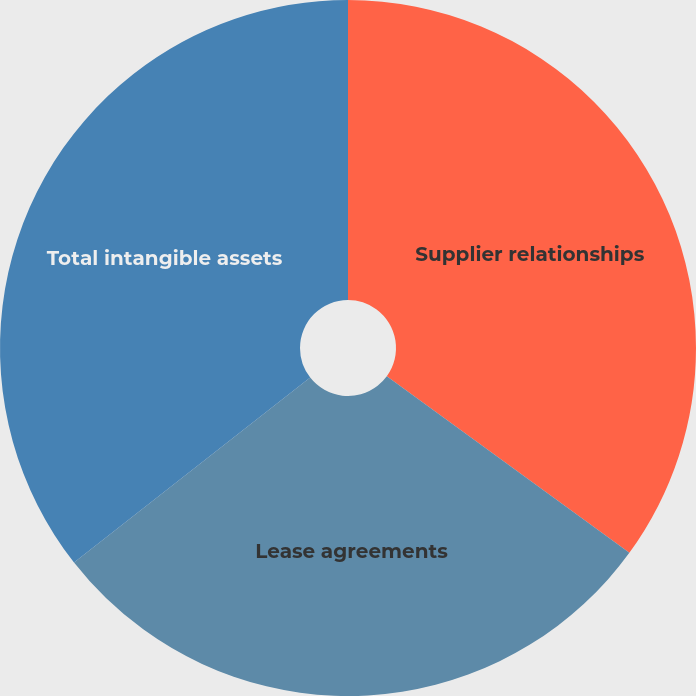Convert chart to OTSL. <chart><loc_0><loc_0><loc_500><loc_500><pie_chart><fcel>Supplier relationships<fcel>Lease agreements<fcel>Total intangible assets<nl><fcel>35.01%<fcel>29.41%<fcel>35.57%<nl></chart> 